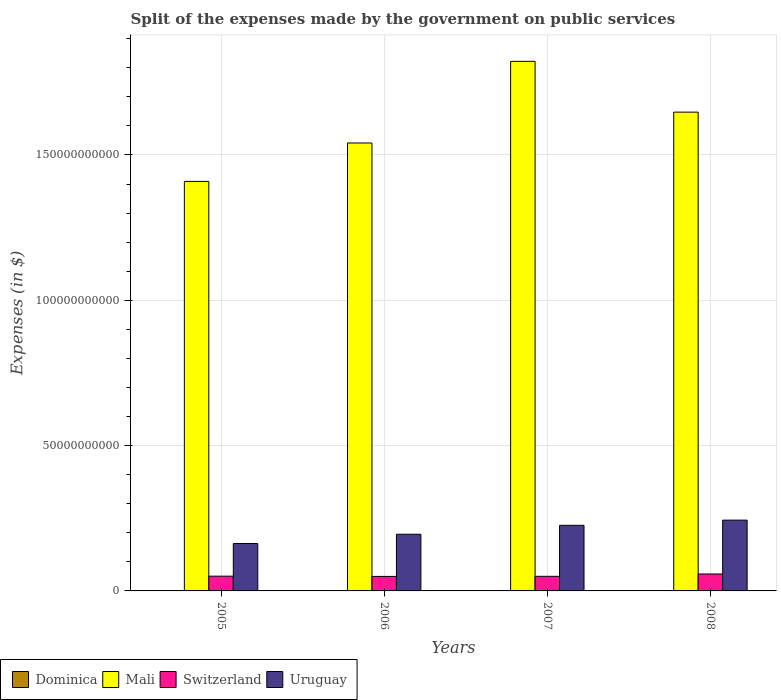How many groups of bars are there?
Your answer should be very brief. 4. Are the number of bars on each tick of the X-axis equal?
Provide a short and direct response. Yes. How many bars are there on the 1st tick from the left?
Your response must be concise. 4. How many bars are there on the 3rd tick from the right?
Offer a terse response. 4. In how many cases, is the number of bars for a given year not equal to the number of legend labels?
Make the answer very short. 0. What is the expenses made by the government on public services in Switzerland in 2006?
Offer a terse response. 4.99e+09. Across all years, what is the maximum expenses made by the government on public services in Switzerland?
Give a very brief answer. 5.83e+09. Across all years, what is the minimum expenses made by the government on public services in Mali?
Offer a terse response. 1.41e+11. In which year was the expenses made by the government on public services in Dominica minimum?
Your response must be concise. 2006. What is the total expenses made by the government on public services in Dominica in the graph?
Your response must be concise. 2.48e+08. What is the difference between the expenses made by the government on public services in Switzerland in 2005 and that in 2006?
Your answer should be very brief. 8.26e+07. What is the difference between the expenses made by the government on public services in Dominica in 2008 and the expenses made by the government on public services in Switzerland in 2007?
Offer a terse response. -4.94e+09. What is the average expenses made by the government on public services in Switzerland per year?
Your answer should be compact. 5.23e+09. In the year 2005, what is the difference between the expenses made by the government on public services in Dominica and expenses made by the government on public services in Uruguay?
Provide a succinct answer. -1.63e+1. What is the ratio of the expenses made by the government on public services in Dominica in 2005 to that in 2008?
Keep it short and to the point. 0.57. Is the expenses made by the government on public services in Mali in 2007 less than that in 2008?
Your answer should be compact. No. Is the difference between the expenses made by the government on public services in Dominica in 2007 and 2008 greater than the difference between the expenses made by the government on public services in Uruguay in 2007 and 2008?
Your answer should be compact. Yes. What is the difference between the highest and the second highest expenses made by the government on public services in Mali?
Your answer should be very brief. 1.75e+1. What is the difference between the highest and the lowest expenses made by the government on public services in Uruguay?
Ensure brevity in your answer.  8.05e+09. In how many years, is the expenses made by the government on public services in Mali greater than the average expenses made by the government on public services in Mali taken over all years?
Give a very brief answer. 2. Is the sum of the expenses made by the government on public services in Switzerland in 2005 and 2008 greater than the maximum expenses made by the government on public services in Dominica across all years?
Offer a very short reply. Yes. What does the 3rd bar from the left in 2008 represents?
Your response must be concise. Switzerland. What does the 4th bar from the right in 2007 represents?
Provide a short and direct response. Dominica. Are all the bars in the graph horizontal?
Offer a terse response. No. How many years are there in the graph?
Ensure brevity in your answer.  4. Where does the legend appear in the graph?
Offer a terse response. Bottom left. How are the legend labels stacked?
Give a very brief answer. Horizontal. What is the title of the graph?
Give a very brief answer. Split of the expenses made by the government on public services. Does "Kuwait" appear as one of the legend labels in the graph?
Your answer should be compact. No. What is the label or title of the X-axis?
Provide a short and direct response. Years. What is the label or title of the Y-axis?
Keep it short and to the point. Expenses (in $). What is the Expenses (in $) in Dominica in 2005?
Offer a very short reply. 5.00e+07. What is the Expenses (in $) in Mali in 2005?
Your response must be concise. 1.41e+11. What is the Expenses (in $) in Switzerland in 2005?
Your answer should be very brief. 5.07e+09. What is the Expenses (in $) in Uruguay in 2005?
Make the answer very short. 1.63e+1. What is the Expenses (in $) of Dominica in 2006?
Provide a succinct answer. 4.67e+07. What is the Expenses (in $) of Mali in 2006?
Your answer should be compact. 1.54e+11. What is the Expenses (in $) of Switzerland in 2006?
Your answer should be compact. 4.99e+09. What is the Expenses (in $) in Uruguay in 2006?
Provide a succinct answer. 1.95e+1. What is the Expenses (in $) in Dominica in 2007?
Your answer should be compact. 6.44e+07. What is the Expenses (in $) in Mali in 2007?
Offer a very short reply. 1.82e+11. What is the Expenses (in $) of Switzerland in 2007?
Offer a very short reply. 5.03e+09. What is the Expenses (in $) of Uruguay in 2007?
Your answer should be compact. 2.26e+1. What is the Expenses (in $) of Dominica in 2008?
Provide a short and direct response. 8.73e+07. What is the Expenses (in $) in Mali in 2008?
Offer a very short reply. 1.65e+11. What is the Expenses (in $) in Switzerland in 2008?
Keep it short and to the point. 5.83e+09. What is the Expenses (in $) in Uruguay in 2008?
Give a very brief answer. 2.44e+1. Across all years, what is the maximum Expenses (in $) of Dominica?
Provide a succinct answer. 8.73e+07. Across all years, what is the maximum Expenses (in $) in Mali?
Offer a very short reply. 1.82e+11. Across all years, what is the maximum Expenses (in $) in Switzerland?
Provide a short and direct response. 5.83e+09. Across all years, what is the maximum Expenses (in $) of Uruguay?
Provide a succinct answer. 2.44e+1. Across all years, what is the minimum Expenses (in $) in Dominica?
Provide a succinct answer. 4.67e+07. Across all years, what is the minimum Expenses (in $) in Mali?
Your answer should be very brief. 1.41e+11. Across all years, what is the minimum Expenses (in $) of Switzerland?
Your answer should be compact. 4.99e+09. Across all years, what is the minimum Expenses (in $) of Uruguay?
Provide a short and direct response. 1.63e+1. What is the total Expenses (in $) in Dominica in the graph?
Offer a terse response. 2.48e+08. What is the total Expenses (in $) in Mali in the graph?
Your answer should be compact. 6.42e+11. What is the total Expenses (in $) of Switzerland in the graph?
Provide a short and direct response. 2.09e+1. What is the total Expenses (in $) in Uruguay in the graph?
Offer a terse response. 8.27e+1. What is the difference between the Expenses (in $) in Dominica in 2005 and that in 2006?
Provide a succinct answer. 3.30e+06. What is the difference between the Expenses (in $) of Mali in 2005 and that in 2006?
Provide a succinct answer. -1.32e+1. What is the difference between the Expenses (in $) of Switzerland in 2005 and that in 2006?
Keep it short and to the point. 8.26e+07. What is the difference between the Expenses (in $) of Uruguay in 2005 and that in 2006?
Give a very brief answer. -3.20e+09. What is the difference between the Expenses (in $) of Dominica in 2005 and that in 2007?
Your response must be concise. -1.44e+07. What is the difference between the Expenses (in $) of Mali in 2005 and that in 2007?
Ensure brevity in your answer.  -4.13e+1. What is the difference between the Expenses (in $) in Switzerland in 2005 and that in 2007?
Ensure brevity in your answer.  4.97e+07. What is the difference between the Expenses (in $) of Uruguay in 2005 and that in 2007?
Your response must be concise. -6.26e+09. What is the difference between the Expenses (in $) of Dominica in 2005 and that in 2008?
Give a very brief answer. -3.73e+07. What is the difference between the Expenses (in $) of Mali in 2005 and that in 2008?
Give a very brief answer. -2.38e+1. What is the difference between the Expenses (in $) of Switzerland in 2005 and that in 2008?
Make the answer very short. -7.52e+08. What is the difference between the Expenses (in $) of Uruguay in 2005 and that in 2008?
Provide a short and direct response. -8.05e+09. What is the difference between the Expenses (in $) in Dominica in 2006 and that in 2007?
Keep it short and to the point. -1.77e+07. What is the difference between the Expenses (in $) in Mali in 2006 and that in 2007?
Offer a terse response. -2.81e+1. What is the difference between the Expenses (in $) of Switzerland in 2006 and that in 2007?
Your answer should be compact. -3.29e+07. What is the difference between the Expenses (in $) of Uruguay in 2006 and that in 2007?
Provide a succinct answer. -3.07e+09. What is the difference between the Expenses (in $) of Dominica in 2006 and that in 2008?
Your answer should be compact. -4.06e+07. What is the difference between the Expenses (in $) in Mali in 2006 and that in 2008?
Ensure brevity in your answer.  -1.06e+1. What is the difference between the Expenses (in $) of Switzerland in 2006 and that in 2008?
Provide a succinct answer. -8.35e+08. What is the difference between the Expenses (in $) of Uruguay in 2006 and that in 2008?
Offer a terse response. -4.85e+09. What is the difference between the Expenses (in $) of Dominica in 2007 and that in 2008?
Your answer should be very brief. -2.29e+07. What is the difference between the Expenses (in $) of Mali in 2007 and that in 2008?
Offer a terse response. 1.75e+1. What is the difference between the Expenses (in $) in Switzerland in 2007 and that in 2008?
Give a very brief answer. -8.02e+08. What is the difference between the Expenses (in $) of Uruguay in 2007 and that in 2008?
Your answer should be very brief. -1.78e+09. What is the difference between the Expenses (in $) in Dominica in 2005 and the Expenses (in $) in Mali in 2006?
Ensure brevity in your answer.  -1.54e+11. What is the difference between the Expenses (in $) of Dominica in 2005 and the Expenses (in $) of Switzerland in 2006?
Give a very brief answer. -4.94e+09. What is the difference between the Expenses (in $) of Dominica in 2005 and the Expenses (in $) of Uruguay in 2006?
Ensure brevity in your answer.  -1.95e+1. What is the difference between the Expenses (in $) of Mali in 2005 and the Expenses (in $) of Switzerland in 2006?
Make the answer very short. 1.36e+11. What is the difference between the Expenses (in $) of Mali in 2005 and the Expenses (in $) of Uruguay in 2006?
Make the answer very short. 1.21e+11. What is the difference between the Expenses (in $) in Switzerland in 2005 and the Expenses (in $) in Uruguay in 2006?
Your response must be concise. -1.44e+1. What is the difference between the Expenses (in $) of Dominica in 2005 and the Expenses (in $) of Mali in 2007?
Ensure brevity in your answer.  -1.82e+11. What is the difference between the Expenses (in $) in Dominica in 2005 and the Expenses (in $) in Switzerland in 2007?
Provide a succinct answer. -4.98e+09. What is the difference between the Expenses (in $) of Dominica in 2005 and the Expenses (in $) of Uruguay in 2007?
Your answer should be very brief. -2.25e+1. What is the difference between the Expenses (in $) in Mali in 2005 and the Expenses (in $) in Switzerland in 2007?
Ensure brevity in your answer.  1.36e+11. What is the difference between the Expenses (in $) in Mali in 2005 and the Expenses (in $) in Uruguay in 2007?
Your response must be concise. 1.18e+11. What is the difference between the Expenses (in $) in Switzerland in 2005 and the Expenses (in $) in Uruguay in 2007?
Your answer should be very brief. -1.75e+1. What is the difference between the Expenses (in $) in Dominica in 2005 and the Expenses (in $) in Mali in 2008?
Your answer should be very brief. -1.65e+11. What is the difference between the Expenses (in $) of Dominica in 2005 and the Expenses (in $) of Switzerland in 2008?
Ensure brevity in your answer.  -5.78e+09. What is the difference between the Expenses (in $) of Dominica in 2005 and the Expenses (in $) of Uruguay in 2008?
Provide a short and direct response. -2.43e+1. What is the difference between the Expenses (in $) in Mali in 2005 and the Expenses (in $) in Switzerland in 2008?
Ensure brevity in your answer.  1.35e+11. What is the difference between the Expenses (in $) of Mali in 2005 and the Expenses (in $) of Uruguay in 2008?
Offer a terse response. 1.17e+11. What is the difference between the Expenses (in $) in Switzerland in 2005 and the Expenses (in $) in Uruguay in 2008?
Your response must be concise. -1.93e+1. What is the difference between the Expenses (in $) of Dominica in 2006 and the Expenses (in $) of Mali in 2007?
Your answer should be compact. -1.82e+11. What is the difference between the Expenses (in $) of Dominica in 2006 and the Expenses (in $) of Switzerland in 2007?
Provide a short and direct response. -4.98e+09. What is the difference between the Expenses (in $) in Dominica in 2006 and the Expenses (in $) in Uruguay in 2007?
Provide a short and direct response. -2.25e+1. What is the difference between the Expenses (in $) of Mali in 2006 and the Expenses (in $) of Switzerland in 2007?
Give a very brief answer. 1.49e+11. What is the difference between the Expenses (in $) in Mali in 2006 and the Expenses (in $) in Uruguay in 2007?
Give a very brief answer. 1.32e+11. What is the difference between the Expenses (in $) in Switzerland in 2006 and the Expenses (in $) in Uruguay in 2007?
Your answer should be compact. -1.76e+1. What is the difference between the Expenses (in $) in Dominica in 2006 and the Expenses (in $) in Mali in 2008?
Your response must be concise. -1.65e+11. What is the difference between the Expenses (in $) in Dominica in 2006 and the Expenses (in $) in Switzerland in 2008?
Provide a short and direct response. -5.78e+09. What is the difference between the Expenses (in $) of Dominica in 2006 and the Expenses (in $) of Uruguay in 2008?
Keep it short and to the point. -2.43e+1. What is the difference between the Expenses (in $) of Mali in 2006 and the Expenses (in $) of Switzerland in 2008?
Keep it short and to the point. 1.48e+11. What is the difference between the Expenses (in $) in Mali in 2006 and the Expenses (in $) in Uruguay in 2008?
Your answer should be compact. 1.30e+11. What is the difference between the Expenses (in $) in Switzerland in 2006 and the Expenses (in $) in Uruguay in 2008?
Offer a terse response. -1.94e+1. What is the difference between the Expenses (in $) in Dominica in 2007 and the Expenses (in $) in Mali in 2008?
Provide a short and direct response. -1.65e+11. What is the difference between the Expenses (in $) of Dominica in 2007 and the Expenses (in $) of Switzerland in 2008?
Give a very brief answer. -5.76e+09. What is the difference between the Expenses (in $) in Dominica in 2007 and the Expenses (in $) in Uruguay in 2008?
Provide a short and direct response. -2.43e+1. What is the difference between the Expenses (in $) in Mali in 2007 and the Expenses (in $) in Switzerland in 2008?
Offer a very short reply. 1.76e+11. What is the difference between the Expenses (in $) in Mali in 2007 and the Expenses (in $) in Uruguay in 2008?
Ensure brevity in your answer.  1.58e+11. What is the difference between the Expenses (in $) of Switzerland in 2007 and the Expenses (in $) of Uruguay in 2008?
Offer a terse response. -1.93e+1. What is the average Expenses (in $) in Dominica per year?
Provide a succinct answer. 6.21e+07. What is the average Expenses (in $) in Mali per year?
Your answer should be compact. 1.60e+11. What is the average Expenses (in $) in Switzerland per year?
Ensure brevity in your answer.  5.23e+09. What is the average Expenses (in $) of Uruguay per year?
Your answer should be very brief. 2.07e+1. In the year 2005, what is the difference between the Expenses (in $) of Dominica and Expenses (in $) of Mali?
Provide a succinct answer. -1.41e+11. In the year 2005, what is the difference between the Expenses (in $) of Dominica and Expenses (in $) of Switzerland?
Provide a short and direct response. -5.02e+09. In the year 2005, what is the difference between the Expenses (in $) of Dominica and Expenses (in $) of Uruguay?
Keep it short and to the point. -1.63e+1. In the year 2005, what is the difference between the Expenses (in $) in Mali and Expenses (in $) in Switzerland?
Your answer should be compact. 1.36e+11. In the year 2005, what is the difference between the Expenses (in $) of Mali and Expenses (in $) of Uruguay?
Offer a terse response. 1.25e+11. In the year 2005, what is the difference between the Expenses (in $) of Switzerland and Expenses (in $) of Uruguay?
Offer a very short reply. -1.12e+1. In the year 2006, what is the difference between the Expenses (in $) of Dominica and Expenses (in $) of Mali?
Your answer should be compact. -1.54e+11. In the year 2006, what is the difference between the Expenses (in $) in Dominica and Expenses (in $) in Switzerland?
Keep it short and to the point. -4.95e+09. In the year 2006, what is the difference between the Expenses (in $) in Dominica and Expenses (in $) in Uruguay?
Ensure brevity in your answer.  -1.95e+1. In the year 2006, what is the difference between the Expenses (in $) of Mali and Expenses (in $) of Switzerland?
Provide a short and direct response. 1.49e+11. In the year 2006, what is the difference between the Expenses (in $) of Mali and Expenses (in $) of Uruguay?
Keep it short and to the point. 1.35e+11. In the year 2006, what is the difference between the Expenses (in $) of Switzerland and Expenses (in $) of Uruguay?
Offer a very short reply. -1.45e+1. In the year 2007, what is the difference between the Expenses (in $) of Dominica and Expenses (in $) of Mali?
Make the answer very short. -1.82e+11. In the year 2007, what is the difference between the Expenses (in $) of Dominica and Expenses (in $) of Switzerland?
Offer a terse response. -4.96e+09. In the year 2007, what is the difference between the Expenses (in $) in Dominica and Expenses (in $) in Uruguay?
Make the answer very short. -2.25e+1. In the year 2007, what is the difference between the Expenses (in $) in Mali and Expenses (in $) in Switzerland?
Ensure brevity in your answer.  1.77e+11. In the year 2007, what is the difference between the Expenses (in $) of Mali and Expenses (in $) of Uruguay?
Your answer should be compact. 1.60e+11. In the year 2007, what is the difference between the Expenses (in $) in Switzerland and Expenses (in $) in Uruguay?
Your answer should be very brief. -1.75e+1. In the year 2008, what is the difference between the Expenses (in $) of Dominica and Expenses (in $) of Mali?
Offer a very short reply. -1.65e+11. In the year 2008, what is the difference between the Expenses (in $) of Dominica and Expenses (in $) of Switzerland?
Give a very brief answer. -5.74e+09. In the year 2008, what is the difference between the Expenses (in $) of Dominica and Expenses (in $) of Uruguay?
Ensure brevity in your answer.  -2.43e+1. In the year 2008, what is the difference between the Expenses (in $) of Mali and Expenses (in $) of Switzerland?
Your answer should be very brief. 1.59e+11. In the year 2008, what is the difference between the Expenses (in $) of Mali and Expenses (in $) of Uruguay?
Offer a terse response. 1.40e+11. In the year 2008, what is the difference between the Expenses (in $) in Switzerland and Expenses (in $) in Uruguay?
Offer a very short reply. -1.85e+1. What is the ratio of the Expenses (in $) in Dominica in 2005 to that in 2006?
Make the answer very short. 1.07. What is the ratio of the Expenses (in $) in Mali in 2005 to that in 2006?
Offer a very short reply. 0.91. What is the ratio of the Expenses (in $) of Switzerland in 2005 to that in 2006?
Provide a short and direct response. 1.02. What is the ratio of the Expenses (in $) of Uruguay in 2005 to that in 2006?
Provide a succinct answer. 0.84. What is the ratio of the Expenses (in $) in Dominica in 2005 to that in 2007?
Your answer should be very brief. 0.78. What is the ratio of the Expenses (in $) in Mali in 2005 to that in 2007?
Make the answer very short. 0.77. What is the ratio of the Expenses (in $) in Switzerland in 2005 to that in 2007?
Give a very brief answer. 1.01. What is the ratio of the Expenses (in $) of Uruguay in 2005 to that in 2007?
Your answer should be compact. 0.72. What is the ratio of the Expenses (in $) of Dominica in 2005 to that in 2008?
Your answer should be very brief. 0.57. What is the ratio of the Expenses (in $) in Mali in 2005 to that in 2008?
Your response must be concise. 0.86. What is the ratio of the Expenses (in $) of Switzerland in 2005 to that in 2008?
Give a very brief answer. 0.87. What is the ratio of the Expenses (in $) of Uruguay in 2005 to that in 2008?
Your answer should be very brief. 0.67. What is the ratio of the Expenses (in $) of Dominica in 2006 to that in 2007?
Provide a succinct answer. 0.73. What is the ratio of the Expenses (in $) in Mali in 2006 to that in 2007?
Provide a succinct answer. 0.85. What is the ratio of the Expenses (in $) in Uruguay in 2006 to that in 2007?
Provide a succinct answer. 0.86. What is the ratio of the Expenses (in $) in Dominica in 2006 to that in 2008?
Offer a terse response. 0.53. What is the ratio of the Expenses (in $) of Mali in 2006 to that in 2008?
Your answer should be very brief. 0.94. What is the ratio of the Expenses (in $) in Switzerland in 2006 to that in 2008?
Ensure brevity in your answer.  0.86. What is the ratio of the Expenses (in $) of Uruguay in 2006 to that in 2008?
Offer a terse response. 0.8. What is the ratio of the Expenses (in $) in Dominica in 2007 to that in 2008?
Give a very brief answer. 0.74. What is the ratio of the Expenses (in $) of Mali in 2007 to that in 2008?
Ensure brevity in your answer.  1.11. What is the ratio of the Expenses (in $) of Switzerland in 2007 to that in 2008?
Ensure brevity in your answer.  0.86. What is the ratio of the Expenses (in $) in Uruguay in 2007 to that in 2008?
Your response must be concise. 0.93. What is the difference between the highest and the second highest Expenses (in $) in Dominica?
Your answer should be compact. 2.29e+07. What is the difference between the highest and the second highest Expenses (in $) of Mali?
Your response must be concise. 1.75e+1. What is the difference between the highest and the second highest Expenses (in $) of Switzerland?
Offer a terse response. 7.52e+08. What is the difference between the highest and the second highest Expenses (in $) of Uruguay?
Offer a terse response. 1.78e+09. What is the difference between the highest and the lowest Expenses (in $) in Dominica?
Ensure brevity in your answer.  4.06e+07. What is the difference between the highest and the lowest Expenses (in $) in Mali?
Keep it short and to the point. 4.13e+1. What is the difference between the highest and the lowest Expenses (in $) of Switzerland?
Make the answer very short. 8.35e+08. What is the difference between the highest and the lowest Expenses (in $) of Uruguay?
Provide a succinct answer. 8.05e+09. 